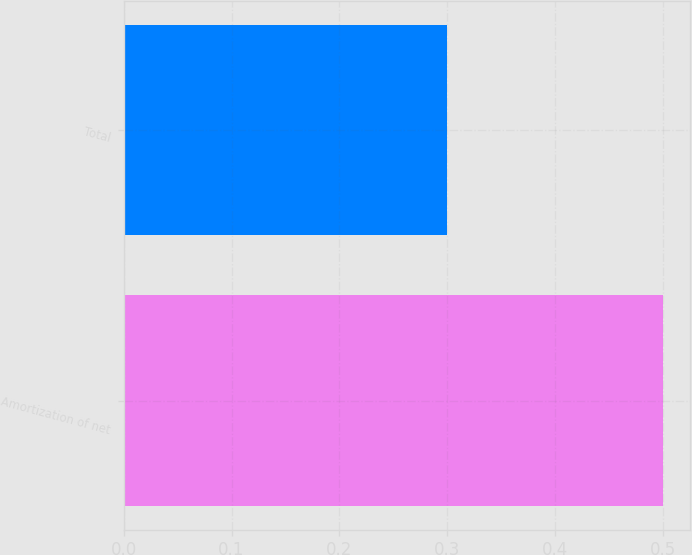Convert chart to OTSL. <chart><loc_0><loc_0><loc_500><loc_500><bar_chart><fcel>Amortization of net<fcel>Total<nl><fcel>0.5<fcel>0.3<nl></chart> 